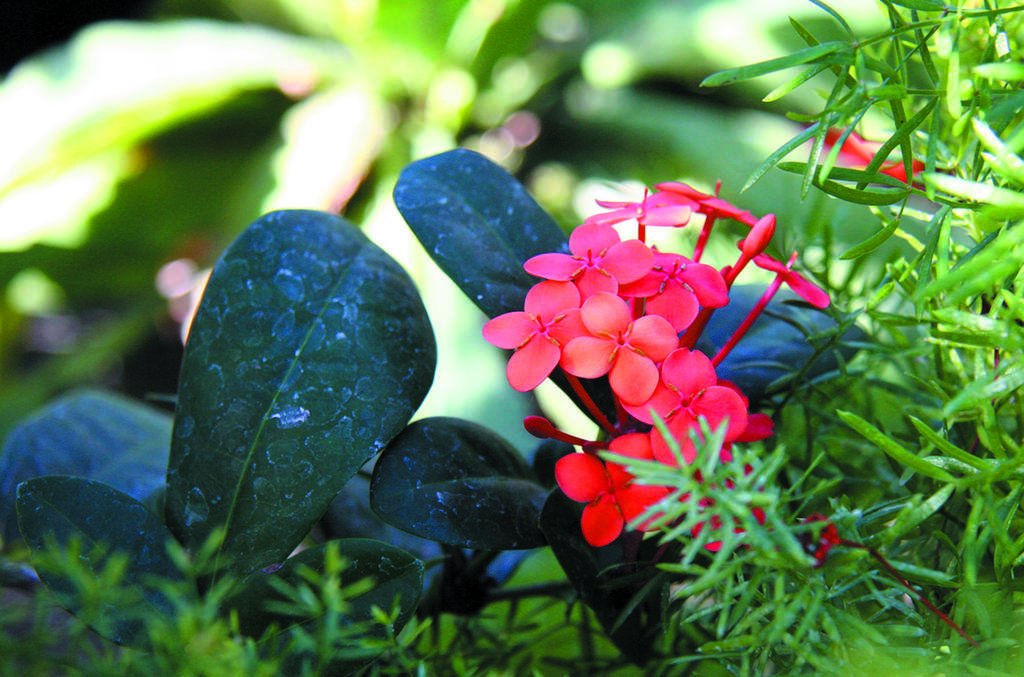What color are the flowers on the plant in the image? The flowers on the plant in the image are red. Where are the leaves located in the image? There are many leaves on the left side of the image. What type of brake can be seen on the airplane in the image? There is no airplane or brake present in the image; it features a plant with red flowers and leaves. How many people are crushed by the plant in the image? There are no people present in the image, and the plant is not crushing anything. 